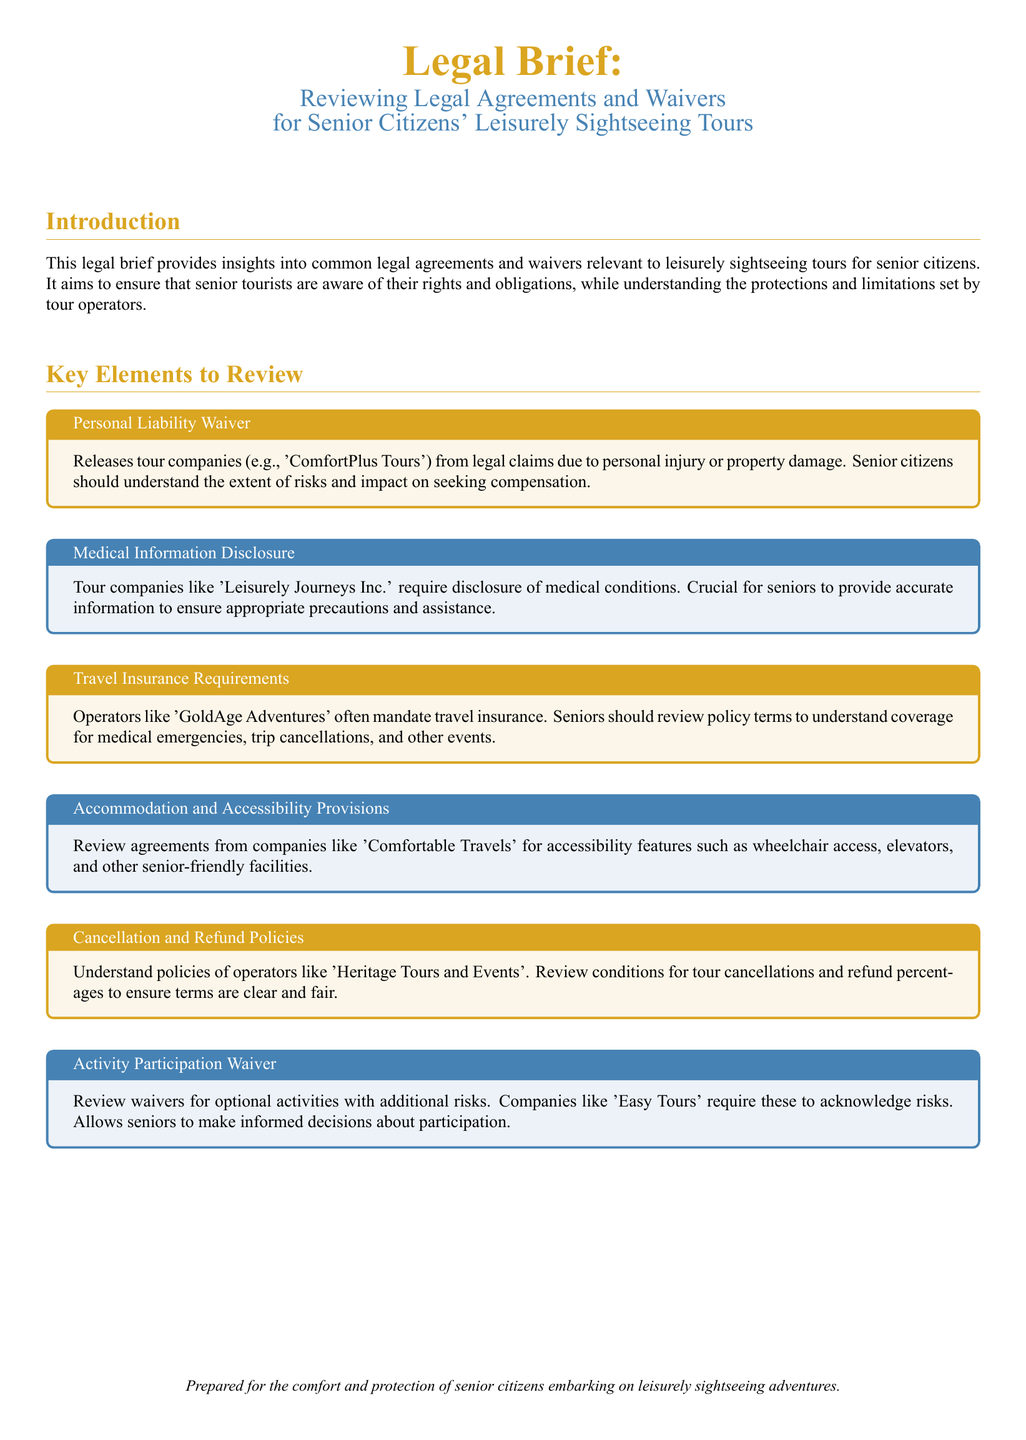What is the purpose of this legal brief? The legal brief aims to provide insights into common legal agreements and waivers relevant to leisurely sightseeing tours for senior citizens.
Answer: Ensure awareness of rights and obligations What tour company is associated with personal liability waivers? The document mentions 'ComfortPlus Tours' in relation to personal liability waivers.
Answer: ComfortPlus Tours Which travel operator requires medical information disclosure? 'Leisurely Journeys Inc.' requires disclosure of medical conditions from seniors.
Answer: Leisurely Journeys Inc What is a key requirement mentioned for travel insurance? The document states that operators like 'GoldAge Adventures' often mandate travel insurance for seniors.
Answer: Travel insurance What should seniors review concerning accommodations? Seniors should review agreements for accessibility features, specifically from 'Comfortable Travels'.
Answer: Comfortable Travels Which company's policies should be examined for cancellations and refunds? Seniors should understand the policies of 'Heritage Tours and Events' regarding cancellations and refunds.
Answer: Heritage Tours and Events What do optional activity waivers allow seniors to acknowledge? Optional activity waivers require seniors to acknowledge the risks of participation in additional activities.
Answer: Risks How many types of key elements are outlined in the document? The document outlines six key elements to review regarding legal agreements and waivers.
Answer: Six 